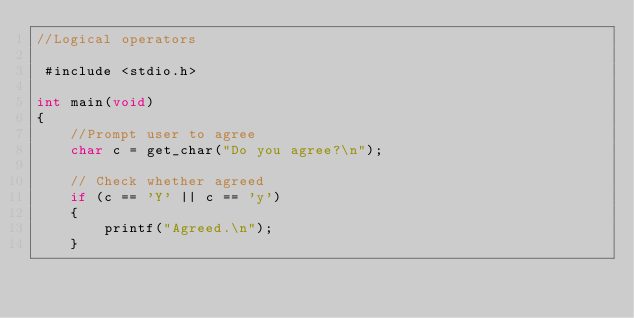<code> <loc_0><loc_0><loc_500><loc_500><_C_>//Logical operators

 #include <stdio.h>

int main(void)
{
    //Prompt user to agree
    char c = get_char("Do you agree?\n");

    // Check whether agreed
    if (c == 'Y' || c == 'y')
    {
        printf("Agreed.\n");
    }</code> 